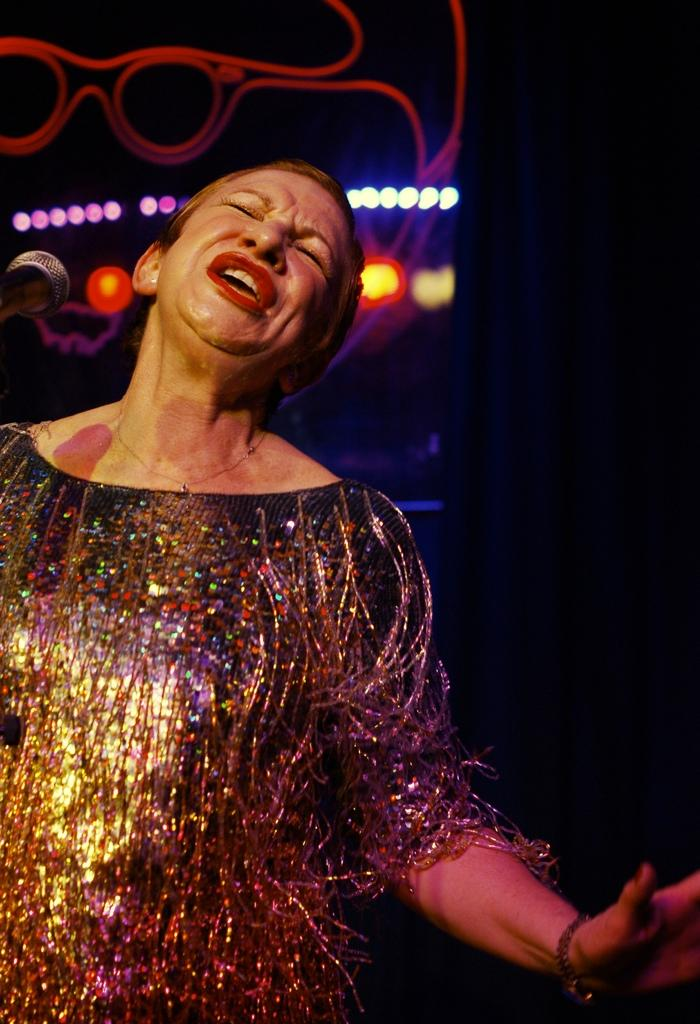Who is the main subject in the image? There is a lady in the image. How would you describe the lady's facial expression? The lady has a weird expression on her face. What can be seen on the wall behind the lady? There are lights on the wall behind her. What type of pets does the lady have in the image? There is no mention of pets in the image, so we cannot determine if the lady has any pets. 